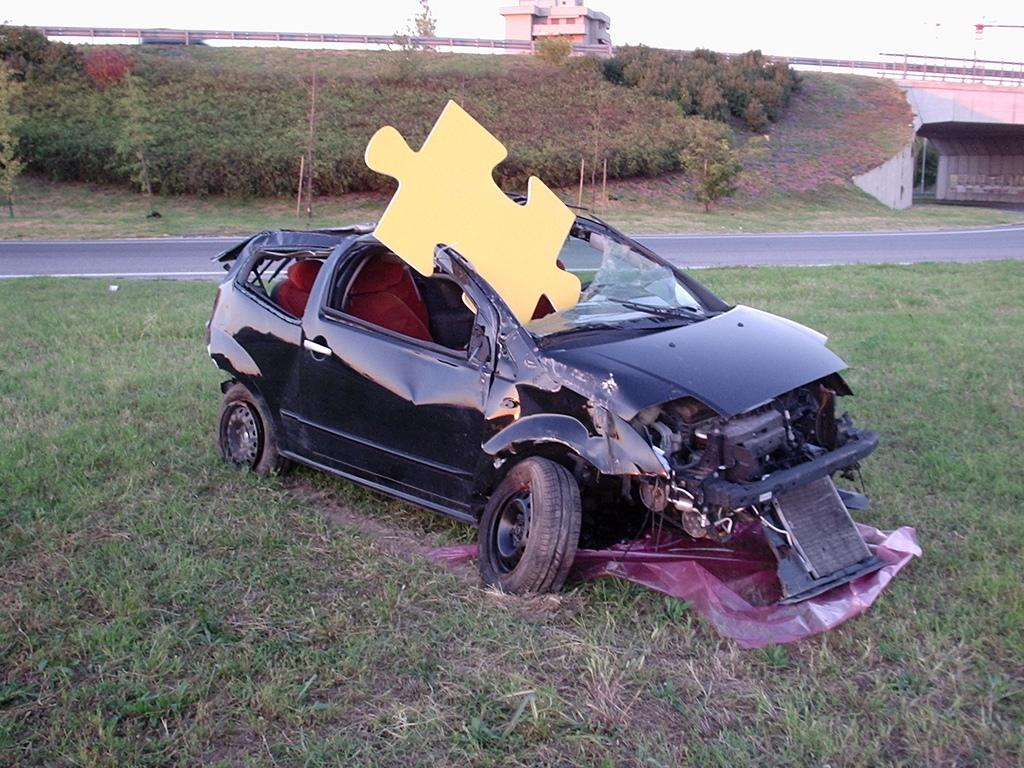What is the condition of the car in the image? The car in the image is black and has visible damage. Where is the car located in the image? The car is on the surface of grassy land. What is behind the car in the image? There is a road behind the car. What can be seen near the road in the image? Plants are present near the road. What is visible in the background of the image? There is a building in the background of the image. What type of rake is being used to clean the car in the image? There is no rake present in the image, and the car is not being cleaned. How does the camera capture the image of the damaged car? The image does not show the process of capturing the image, only the final result. 